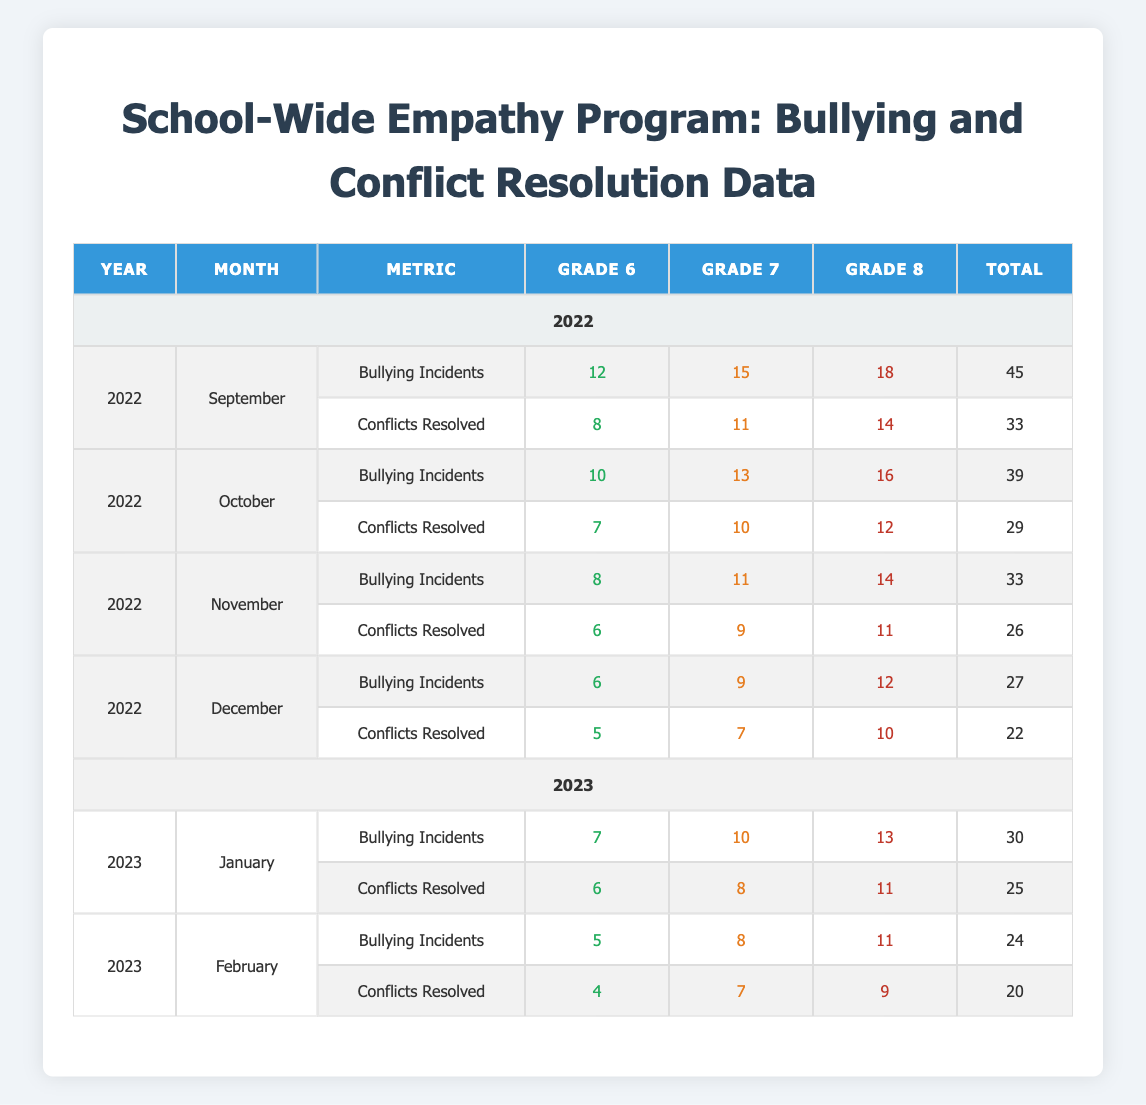What was the highest number of bullying incidents recorded in any grade in September 2022? In September 2022, Grade 6 had 12, Grade 7 had 15, and Grade 8 had 18 bullying incidents. The highest number among these is 18 in Grade 8.
Answer: 18 How many total conflicts were resolved in November 2022? In November 2022, the conflicts resolved were 6 in Grade 6, 9 in Grade 7, and 11 in Grade 8. Adding these gives 6 + 9 + 11 = 26 conflicts resolved in total.
Answer: 26 Did the number of bullying incidents increase or decrease from December 2022 to January 2023? In December 2022, there were 6 incidents in Grade 6, 9 in Grade 7, and 12 in Grade 8, totaling 27, while in January 2023, there were 7 in Grade 6, 10 in Grade 7, and 13 in Grade 8, totaling 30. Therefore, the incidents increased from 27 to 30.
Answer: Increase What is the average number of conflicts resolved per grade in January 2023? In January 2023, conflicts resolved were 6 for Grade 6, 8 for Grade 7, and 11 for Grade 8. To find the average, we calculate the total (6 + 8 + 11 = 25) and divide by the number of grades (3), yielding an average of 25 / 3 = 8.33.
Answer: 8.33 Which month and grade had the fewest bullying incidents in the given data? In February 2023, there were 5 bullying incidents in Grade 6, which is the lowest number when comparing all other months and grades.
Answer: February 2023, Grade 6 How much more did Grade 7 resolve compared to Grade 6 in October 2022? In October 2022, Grade 7 resolved 10 conflicts while Grade 6 resolved 7. The difference is 10 - 7 = 3, meaning Grade 7 resolved 3 more conflicts than Grade 6.
Answer: 3 What was the total number of bullying incidents across all grades in December 2022? In December 2022, there were 6 incidents in Grade 6, 9 in Grade 7, and 12 in Grade 8, with a total of 6 + 9 + 12 = 27 bullying incidents across all grades for that month.
Answer: 27 Is it true that Grade 8 experienced more bullying incidents than Grade 6 in every month recorded? Reviewing the data, in September, October, November, December, January, and February, Grade 8 consistently had more incidents than Grade 6. Thus, the statement is true.
Answer: True 